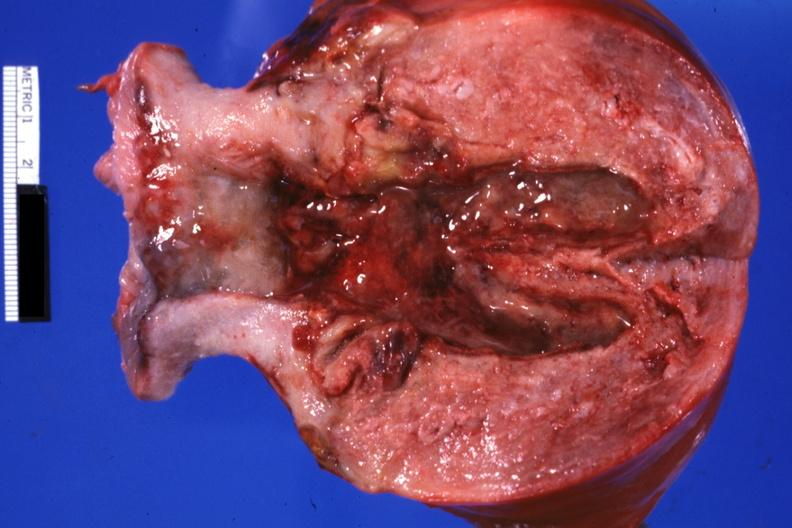s female reproductive present?
Answer the question using a single word or phrase. Yes 